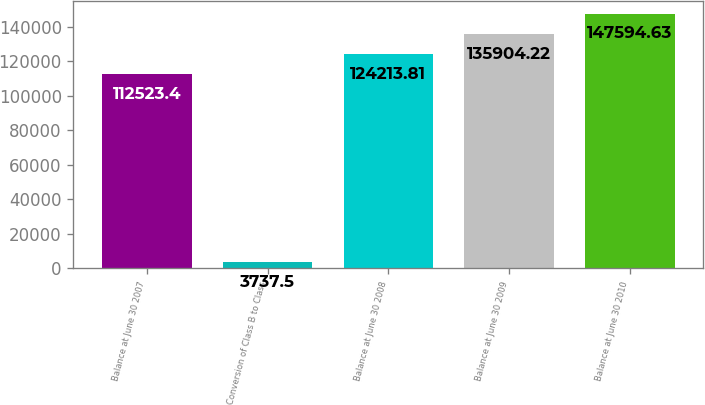Convert chart to OTSL. <chart><loc_0><loc_0><loc_500><loc_500><bar_chart><fcel>Balance at June 30 2007<fcel>Conversion of Class B to Class<fcel>Balance at June 30 2008<fcel>Balance at June 30 2009<fcel>Balance at June 30 2010<nl><fcel>112523<fcel>3737.5<fcel>124214<fcel>135904<fcel>147595<nl></chart> 